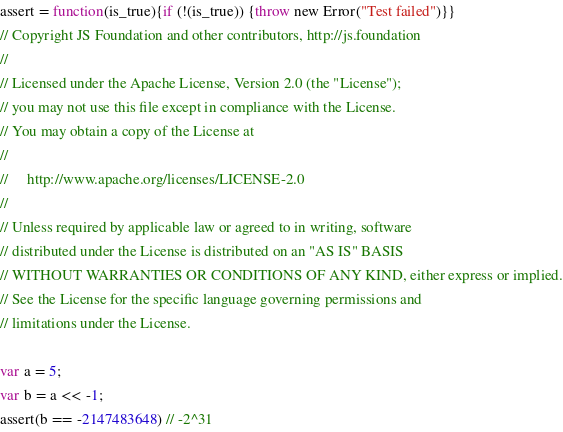<code> <loc_0><loc_0><loc_500><loc_500><_JavaScript_>assert = function(is_true){if (!(is_true)) {throw new Error("Test failed")}} 
// Copyright JS Foundation and other contributors, http://js.foundation
//
// Licensed under the Apache License, Version 2.0 (the "License");
// you may not use this file except in compliance with the License.
// You may obtain a copy of the License at
//
//     http://www.apache.org/licenses/LICENSE-2.0
//
// Unless required by applicable law or agreed to in writing, software
// distributed under the License is distributed on an "AS IS" BASIS
// WITHOUT WARRANTIES OR CONDITIONS OF ANY KIND, either express or implied.
// See the License for the specific language governing permissions and
// limitations under the License.

var a = 5;
var b = a << -1;
assert(b == -2147483648) // -2^31</code> 